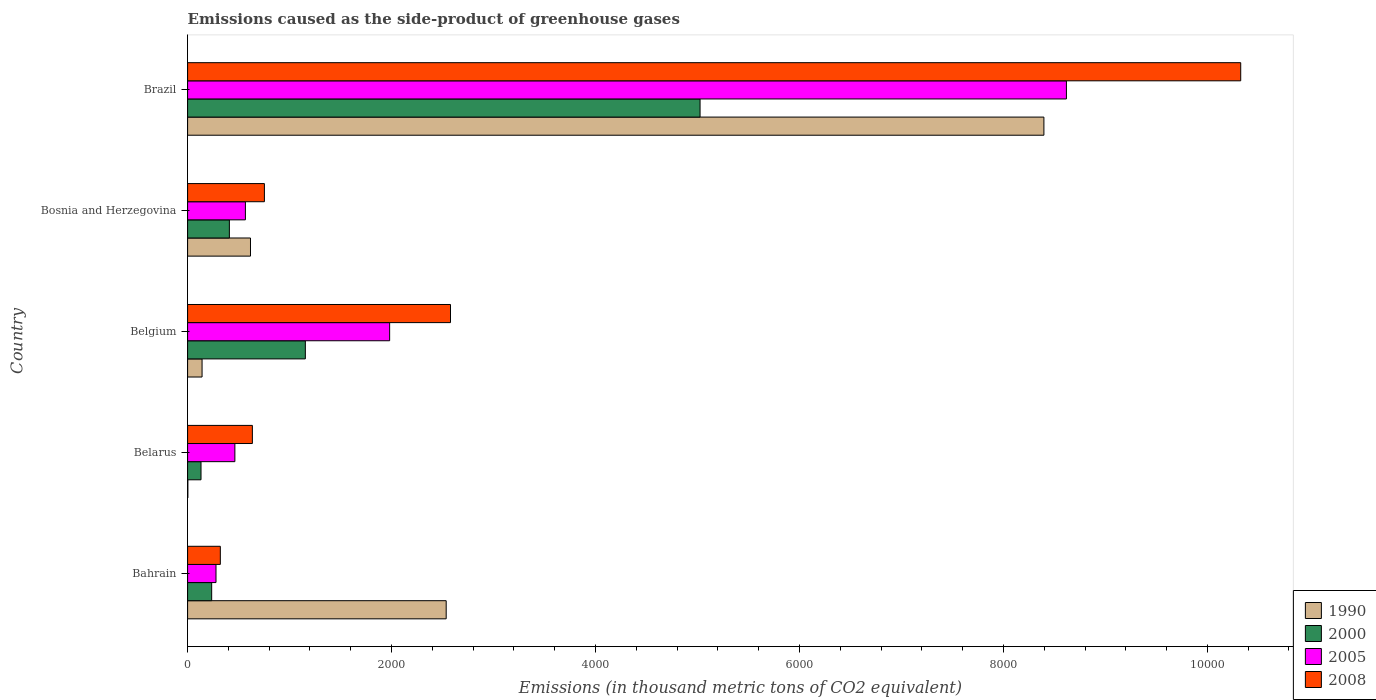Are the number of bars per tick equal to the number of legend labels?
Offer a terse response. Yes. Are the number of bars on each tick of the Y-axis equal?
Offer a very short reply. Yes. How many bars are there on the 4th tick from the top?
Provide a short and direct response. 4. How many bars are there on the 2nd tick from the bottom?
Your answer should be very brief. 4. What is the label of the 2nd group of bars from the top?
Your response must be concise. Bosnia and Herzegovina. In how many cases, is the number of bars for a given country not equal to the number of legend labels?
Offer a very short reply. 0. What is the emissions caused as the side-product of greenhouse gases in 1990 in Brazil?
Your response must be concise. 8396.7. Across all countries, what is the maximum emissions caused as the side-product of greenhouse gases in 2008?
Provide a short and direct response. 1.03e+04. Across all countries, what is the minimum emissions caused as the side-product of greenhouse gases in 2000?
Offer a very short reply. 131.6. In which country was the emissions caused as the side-product of greenhouse gases in 2005 minimum?
Make the answer very short. Bahrain. What is the total emissions caused as the side-product of greenhouse gases in 2008 in the graph?
Your answer should be compact. 1.46e+04. What is the difference between the emissions caused as the side-product of greenhouse gases in 1990 in Bahrain and that in Bosnia and Herzegovina?
Keep it short and to the point. 1919. What is the difference between the emissions caused as the side-product of greenhouse gases in 2000 in Bahrain and the emissions caused as the side-product of greenhouse gases in 1990 in Belarus?
Provide a short and direct response. 233.5. What is the average emissions caused as the side-product of greenhouse gases in 1990 per country?
Your response must be concise. 2338.72. What is the difference between the emissions caused as the side-product of greenhouse gases in 2008 and emissions caused as the side-product of greenhouse gases in 2005 in Brazil?
Your answer should be very brief. 1709.1. In how many countries, is the emissions caused as the side-product of greenhouse gases in 2005 greater than 6400 thousand metric tons?
Your response must be concise. 1. What is the ratio of the emissions caused as the side-product of greenhouse gases in 2005 in Belarus to that in Bosnia and Herzegovina?
Your answer should be very brief. 0.82. What is the difference between the highest and the second highest emissions caused as the side-product of greenhouse gases in 2008?
Your response must be concise. 7748.6. What is the difference between the highest and the lowest emissions caused as the side-product of greenhouse gases in 2005?
Offer a very short reply. 8338.9. In how many countries, is the emissions caused as the side-product of greenhouse gases in 2008 greater than the average emissions caused as the side-product of greenhouse gases in 2008 taken over all countries?
Give a very brief answer. 1. Is the sum of the emissions caused as the side-product of greenhouse gases in 2005 in Belgium and Brazil greater than the maximum emissions caused as the side-product of greenhouse gases in 2008 across all countries?
Your response must be concise. Yes. What does the 2nd bar from the top in Brazil represents?
Offer a very short reply. 2005. Is it the case that in every country, the sum of the emissions caused as the side-product of greenhouse gases in 2005 and emissions caused as the side-product of greenhouse gases in 2000 is greater than the emissions caused as the side-product of greenhouse gases in 2008?
Give a very brief answer. No. Are the values on the major ticks of X-axis written in scientific E-notation?
Your answer should be very brief. No. Does the graph contain any zero values?
Offer a very short reply. No. How many legend labels are there?
Your answer should be very brief. 4. What is the title of the graph?
Keep it short and to the point. Emissions caused as the side-product of greenhouse gases. What is the label or title of the X-axis?
Ensure brevity in your answer.  Emissions (in thousand metric tons of CO2 equivalent). What is the label or title of the Y-axis?
Your answer should be very brief. Country. What is the Emissions (in thousand metric tons of CO2 equivalent) of 1990 in Bahrain?
Your answer should be very brief. 2535.7. What is the Emissions (in thousand metric tons of CO2 equivalent) of 2000 in Bahrain?
Your answer should be very brief. 236.1. What is the Emissions (in thousand metric tons of CO2 equivalent) of 2005 in Bahrain?
Provide a succinct answer. 278.6. What is the Emissions (in thousand metric tons of CO2 equivalent) in 2008 in Bahrain?
Your answer should be very brief. 320.9. What is the Emissions (in thousand metric tons of CO2 equivalent) of 1990 in Belarus?
Provide a short and direct response. 2.6. What is the Emissions (in thousand metric tons of CO2 equivalent) of 2000 in Belarus?
Make the answer very short. 131.6. What is the Emissions (in thousand metric tons of CO2 equivalent) in 2005 in Belarus?
Give a very brief answer. 463.6. What is the Emissions (in thousand metric tons of CO2 equivalent) in 2008 in Belarus?
Offer a terse response. 635.2. What is the Emissions (in thousand metric tons of CO2 equivalent) of 1990 in Belgium?
Offer a very short reply. 141.9. What is the Emissions (in thousand metric tons of CO2 equivalent) of 2000 in Belgium?
Keep it short and to the point. 1154.6. What is the Emissions (in thousand metric tons of CO2 equivalent) of 2005 in Belgium?
Provide a short and direct response. 1981.2. What is the Emissions (in thousand metric tons of CO2 equivalent) in 2008 in Belgium?
Provide a succinct answer. 2578. What is the Emissions (in thousand metric tons of CO2 equivalent) in 1990 in Bosnia and Herzegovina?
Provide a short and direct response. 616.7. What is the Emissions (in thousand metric tons of CO2 equivalent) of 2000 in Bosnia and Herzegovina?
Your response must be concise. 409.7. What is the Emissions (in thousand metric tons of CO2 equivalent) of 2005 in Bosnia and Herzegovina?
Give a very brief answer. 566.9. What is the Emissions (in thousand metric tons of CO2 equivalent) of 2008 in Bosnia and Herzegovina?
Provide a succinct answer. 753.2. What is the Emissions (in thousand metric tons of CO2 equivalent) of 1990 in Brazil?
Offer a terse response. 8396.7. What is the Emissions (in thousand metric tons of CO2 equivalent) of 2000 in Brazil?
Keep it short and to the point. 5025.2. What is the Emissions (in thousand metric tons of CO2 equivalent) in 2005 in Brazil?
Provide a short and direct response. 8617.5. What is the Emissions (in thousand metric tons of CO2 equivalent) in 2008 in Brazil?
Your answer should be very brief. 1.03e+04. Across all countries, what is the maximum Emissions (in thousand metric tons of CO2 equivalent) in 1990?
Offer a very short reply. 8396.7. Across all countries, what is the maximum Emissions (in thousand metric tons of CO2 equivalent) of 2000?
Give a very brief answer. 5025.2. Across all countries, what is the maximum Emissions (in thousand metric tons of CO2 equivalent) in 2005?
Ensure brevity in your answer.  8617.5. Across all countries, what is the maximum Emissions (in thousand metric tons of CO2 equivalent) in 2008?
Your answer should be very brief. 1.03e+04. Across all countries, what is the minimum Emissions (in thousand metric tons of CO2 equivalent) in 2000?
Your answer should be very brief. 131.6. Across all countries, what is the minimum Emissions (in thousand metric tons of CO2 equivalent) of 2005?
Offer a terse response. 278.6. Across all countries, what is the minimum Emissions (in thousand metric tons of CO2 equivalent) in 2008?
Your response must be concise. 320.9. What is the total Emissions (in thousand metric tons of CO2 equivalent) of 1990 in the graph?
Offer a terse response. 1.17e+04. What is the total Emissions (in thousand metric tons of CO2 equivalent) in 2000 in the graph?
Your response must be concise. 6957.2. What is the total Emissions (in thousand metric tons of CO2 equivalent) in 2005 in the graph?
Make the answer very short. 1.19e+04. What is the total Emissions (in thousand metric tons of CO2 equivalent) of 2008 in the graph?
Provide a succinct answer. 1.46e+04. What is the difference between the Emissions (in thousand metric tons of CO2 equivalent) of 1990 in Bahrain and that in Belarus?
Give a very brief answer. 2533.1. What is the difference between the Emissions (in thousand metric tons of CO2 equivalent) of 2000 in Bahrain and that in Belarus?
Ensure brevity in your answer.  104.5. What is the difference between the Emissions (in thousand metric tons of CO2 equivalent) in 2005 in Bahrain and that in Belarus?
Your response must be concise. -185. What is the difference between the Emissions (in thousand metric tons of CO2 equivalent) of 2008 in Bahrain and that in Belarus?
Provide a short and direct response. -314.3. What is the difference between the Emissions (in thousand metric tons of CO2 equivalent) in 1990 in Bahrain and that in Belgium?
Offer a very short reply. 2393.8. What is the difference between the Emissions (in thousand metric tons of CO2 equivalent) in 2000 in Bahrain and that in Belgium?
Ensure brevity in your answer.  -918.5. What is the difference between the Emissions (in thousand metric tons of CO2 equivalent) of 2005 in Bahrain and that in Belgium?
Your response must be concise. -1702.6. What is the difference between the Emissions (in thousand metric tons of CO2 equivalent) in 2008 in Bahrain and that in Belgium?
Your response must be concise. -2257.1. What is the difference between the Emissions (in thousand metric tons of CO2 equivalent) in 1990 in Bahrain and that in Bosnia and Herzegovina?
Offer a terse response. 1919. What is the difference between the Emissions (in thousand metric tons of CO2 equivalent) of 2000 in Bahrain and that in Bosnia and Herzegovina?
Make the answer very short. -173.6. What is the difference between the Emissions (in thousand metric tons of CO2 equivalent) of 2005 in Bahrain and that in Bosnia and Herzegovina?
Offer a very short reply. -288.3. What is the difference between the Emissions (in thousand metric tons of CO2 equivalent) of 2008 in Bahrain and that in Bosnia and Herzegovina?
Provide a succinct answer. -432.3. What is the difference between the Emissions (in thousand metric tons of CO2 equivalent) in 1990 in Bahrain and that in Brazil?
Provide a short and direct response. -5861. What is the difference between the Emissions (in thousand metric tons of CO2 equivalent) of 2000 in Bahrain and that in Brazil?
Make the answer very short. -4789.1. What is the difference between the Emissions (in thousand metric tons of CO2 equivalent) in 2005 in Bahrain and that in Brazil?
Your response must be concise. -8338.9. What is the difference between the Emissions (in thousand metric tons of CO2 equivalent) in 2008 in Bahrain and that in Brazil?
Provide a succinct answer. -1.00e+04. What is the difference between the Emissions (in thousand metric tons of CO2 equivalent) of 1990 in Belarus and that in Belgium?
Make the answer very short. -139.3. What is the difference between the Emissions (in thousand metric tons of CO2 equivalent) in 2000 in Belarus and that in Belgium?
Your answer should be compact. -1023. What is the difference between the Emissions (in thousand metric tons of CO2 equivalent) in 2005 in Belarus and that in Belgium?
Your response must be concise. -1517.6. What is the difference between the Emissions (in thousand metric tons of CO2 equivalent) of 2008 in Belarus and that in Belgium?
Give a very brief answer. -1942.8. What is the difference between the Emissions (in thousand metric tons of CO2 equivalent) in 1990 in Belarus and that in Bosnia and Herzegovina?
Ensure brevity in your answer.  -614.1. What is the difference between the Emissions (in thousand metric tons of CO2 equivalent) of 2000 in Belarus and that in Bosnia and Herzegovina?
Your answer should be very brief. -278.1. What is the difference between the Emissions (in thousand metric tons of CO2 equivalent) in 2005 in Belarus and that in Bosnia and Herzegovina?
Offer a terse response. -103.3. What is the difference between the Emissions (in thousand metric tons of CO2 equivalent) in 2008 in Belarus and that in Bosnia and Herzegovina?
Offer a very short reply. -118. What is the difference between the Emissions (in thousand metric tons of CO2 equivalent) of 1990 in Belarus and that in Brazil?
Ensure brevity in your answer.  -8394.1. What is the difference between the Emissions (in thousand metric tons of CO2 equivalent) in 2000 in Belarus and that in Brazil?
Ensure brevity in your answer.  -4893.6. What is the difference between the Emissions (in thousand metric tons of CO2 equivalent) of 2005 in Belarus and that in Brazil?
Make the answer very short. -8153.9. What is the difference between the Emissions (in thousand metric tons of CO2 equivalent) of 2008 in Belarus and that in Brazil?
Offer a very short reply. -9691.4. What is the difference between the Emissions (in thousand metric tons of CO2 equivalent) in 1990 in Belgium and that in Bosnia and Herzegovina?
Ensure brevity in your answer.  -474.8. What is the difference between the Emissions (in thousand metric tons of CO2 equivalent) in 2000 in Belgium and that in Bosnia and Herzegovina?
Provide a succinct answer. 744.9. What is the difference between the Emissions (in thousand metric tons of CO2 equivalent) of 2005 in Belgium and that in Bosnia and Herzegovina?
Your response must be concise. 1414.3. What is the difference between the Emissions (in thousand metric tons of CO2 equivalent) in 2008 in Belgium and that in Bosnia and Herzegovina?
Your answer should be very brief. 1824.8. What is the difference between the Emissions (in thousand metric tons of CO2 equivalent) in 1990 in Belgium and that in Brazil?
Offer a very short reply. -8254.8. What is the difference between the Emissions (in thousand metric tons of CO2 equivalent) of 2000 in Belgium and that in Brazil?
Your answer should be very brief. -3870.6. What is the difference between the Emissions (in thousand metric tons of CO2 equivalent) in 2005 in Belgium and that in Brazil?
Give a very brief answer. -6636.3. What is the difference between the Emissions (in thousand metric tons of CO2 equivalent) of 2008 in Belgium and that in Brazil?
Ensure brevity in your answer.  -7748.6. What is the difference between the Emissions (in thousand metric tons of CO2 equivalent) in 1990 in Bosnia and Herzegovina and that in Brazil?
Provide a short and direct response. -7780. What is the difference between the Emissions (in thousand metric tons of CO2 equivalent) of 2000 in Bosnia and Herzegovina and that in Brazil?
Give a very brief answer. -4615.5. What is the difference between the Emissions (in thousand metric tons of CO2 equivalent) of 2005 in Bosnia and Herzegovina and that in Brazil?
Ensure brevity in your answer.  -8050.6. What is the difference between the Emissions (in thousand metric tons of CO2 equivalent) in 2008 in Bosnia and Herzegovina and that in Brazil?
Ensure brevity in your answer.  -9573.4. What is the difference between the Emissions (in thousand metric tons of CO2 equivalent) of 1990 in Bahrain and the Emissions (in thousand metric tons of CO2 equivalent) of 2000 in Belarus?
Ensure brevity in your answer.  2404.1. What is the difference between the Emissions (in thousand metric tons of CO2 equivalent) of 1990 in Bahrain and the Emissions (in thousand metric tons of CO2 equivalent) of 2005 in Belarus?
Offer a terse response. 2072.1. What is the difference between the Emissions (in thousand metric tons of CO2 equivalent) of 1990 in Bahrain and the Emissions (in thousand metric tons of CO2 equivalent) of 2008 in Belarus?
Give a very brief answer. 1900.5. What is the difference between the Emissions (in thousand metric tons of CO2 equivalent) in 2000 in Bahrain and the Emissions (in thousand metric tons of CO2 equivalent) in 2005 in Belarus?
Provide a succinct answer. -227.5. What is the difference between the Emissions (in thousand metric tons of CO2 equivalent) of 2000 in Bahrain and the Emissions (in thousand metric tons of CO2 equivalent) of 2008 in Belarus?
Ensure brevity in your answer.  -399.1. What is the difference between the Emissions (in thousand metric tons of CO2 equivalent) in 2005 in Bahrain and the Emissions (in thousand metric tons of CO2 equivalent) in 2008 in Belarus?
Make the answer very short. -356.6. What is the difference between the Emissions (in thousand metric tons of CO2 equivalent) in 1990 in Bahrain and the Emissions (in thousand metric tons of CO2 equivalent) in 2000 in Belgium?
Your answer should be very brief. 1381.1. What is the difference between the Emissions (in thousand metric tons of CO2 equivalent) in 1990 in Bahrain and the Emissions (in thousand metric tons of CO2 equivalent) in 2005 in Belgium?
Keep it short and to the point. 554.5. What is the difference between the Emissions (in thousand metric tons of CO2 equivalent) of 1990 in Bahrain and the Emissions (in thousand metric tons of CO2 equivalent) of 2008 in Belgium?
Provide a short and direct response. -42.3. What is the difference between the Emissions (in thousand metric tons of CO2 equivalent) in 2000 in Bahrain and the Emissions (in thousand metric tons of CO2 equivalent) in 2005 in Belgium?
Provide a short and direct response. -1745.1. What is the difference between the Emissions (in thousand metric tons of CO2 equivalent) in 2000 in Bahrain and the Emissions (in thousand metric tons of CO2 equivalent) in 2008 in Belgium?
Your answer should be very brief. -2341.9. What is the difference between the Emissions (in thousand metric tons of CO2 equivalent) in 2005 in Bahrain and the Emissions (in thousand metric tons of CO2 equivalent) in 2008 in Belgium?
Offer a very short reply. -2299.4. What is the difference between the Emissions (in thousand metric tons of CO2 equivalent) of 1990 in Bahrain and the Emissions (in thousand metric tons of CO2 equivalent) of 2000 in Bosnia and Herzegovina?
Give a very brief answer. 2126. What is the difference between the Emissions (in thousand metric tons of CO2 equivalent) of 1990 in Bahrain and the Emissions (in thousand metric tons of CO2 equivalent) of 2005 in Bosnia and Herzegovina?
Your answer should be compact. 1968.8. What is the difference between the Emissions (in thousand metric tons of CO2 equivalent) in 1990 in Bahrain and the Emissions (in thousand metric tons of CO2 equivalent) in 2008 in Bosnia and Herzegovina?
Offer a terse response. 1782.5. What is the difference between the Emissions (in thousand metric tons of CO2 equivalent) of 2000 in Bahrain and the Emissions (in thousand metric tons of CO2 equivalent) of 2005 in Bosnia and Herzegovina?
Ensure brevity in your answer.  -330.8. What is the difference between the Emissions (in thousand metric tons of CO2 equivalent) in 2000 in Bahrain and the Emissions (in thousand metric tons of CO2 equivalent) in 2008 in Bosnia and Herzegovina?
Your answer should be very brief. -517.1. What is the difference between the Emissions (in thousand metric tons of CO2 equivalent) in 2005 in Bahrain and the Emissions (in thousand metric tons of CO2 equivalent) in 2008 in Bosnia and Herzegovina?
Keep it short and to the point. -474.6. What is the difference between the Emissions (in thousand metric tons of CO2 equivalent) of 1990 in Bahrain and the Emissions (in thousand metric tons of CO2 equivalent) of 2000 in Brazil?
Provide a succinct answer. -2489.5. What is the difference between the Emissions (in thousand metric tons of CO2 equivalent) of 1990 in Bahrain and the Emissions (in thousand metric tons of CO2 equivalent) of 2005 in Brazil?
Keep it short and to the point. -6081.8. What is the difference between the Emissions (in thousand metric tons of CO2 equivalent) in 1990 in Bahrain and the Emissions (in thousand metric tons of CO2 equivalent) in 2008 in Brazil?
Give a very brief answer. -7790.9. What is the difference between the Emissions (in thousand metric tons of CO2 equivalent) of 2000 in Bahrain and the Emissions (in thousand metric tons of CO2 equivalent) of 2005 in Brazil?
Provide a short and direct response. -8381.4. What is the difference between the Emissions (in thousand metric tons of CO2 equivalent) of 2000 in Bahrain and the Emissions (in thousand metric tons of CO2 equivalent) of 2008 in Brazil?
Give a very brief answer. -1.01e+04. What is the difference between the Emissions (in thousand metric tons of CO2 equivalent) of 2005 in Bahrain and the Emissions (in thousand metric tons of CO2 equivalent) of 2008 in Brazil?
Your answer should be compact. -1.00e+04. What is the difference between the Emissions (in thousand metric tons of CO2 equivalent) in 1990 in Belarus and the Emissions (in thousand metric tons of CO2 equivalent) in 2000 in Belgium?
Keep it short and to the point. -1152. What is the difference between the Emissions (in thousand metric tons of CO2 equivalent) of 1990 in Belarus and the Emissions (in thousand metric tons of CO2 equivalent) of 2005 in Belgium?
Your response must be concise. -1978.6. What is the difference between the Emissions (in thousand metric tons of CO2 equivalent) of 1990 in Belarus and the Emissions (in thousand metric tons of CO2 equivalent) of 2008 in Belgium?
Your response must be concise. -2575.4. What is the difference between the Emissions (in thousand metric tons of CO2 equivalent) of 2000 in Belarus and the Emissions (in thousand metric tons of CO2 equivalent) of 2005 in Belgium?
Ensure brevity in your answer.  -1849.6. What is the difference between the Emissions (in thousand metric tons of CO2 equivalent) in 2000 in Belarus and the Emissions (in thousand metric tons of CO2 equivalent) in 2008 in Belgium?
Your response must be concise. -2446.4. What is the difference between the Emissions (in thousand metric tons of CO2 equivalent) in 2005 in Belarus and the Emissions (in thousand metric tons of CO2 equivalent) in 2008 in Belgium?
Your answer should be very brief. -2114.4. What is the difference between the Emissions (in thousand metric tons of CO2 equivalent) of 1990 in Belarus and the Emissions (in thousand metric tons of CO2 equivalent) of 2000 in Bosnia and Herzegovina?
Offer a very short reply. -407.1. What is the difference between the Emissions (in thousand metric tons of CO2 equivalent) of 1990 in Belarus and the Emissions (in thousand metric tons of CO2 equivalent) of 2005 in Bosnia and Herzegovina?
Your answer should be very brief. -564.3. What is the difference between the Emissions (in thousand metric tons of CO2 equivalent) in 1990 in Belarus and the Emissions (in thousand metric tons of CO2 equivalent) in 2008 in Bosnia and Herzegovina?
Provide a succinct answer. -750.6. What is the difference between the Emissions (in thousand metric tons of CO2 equivalent) in 2000 in Belarus and the Emissions (in thousand metric tons of CO2 equivalent) in 2005 in Bosnia and Herzegovina?
Provide a succinct answer. -435.3. What is the difference between the Emissions (in thousand metric tons of CO2 equivalent) in 2000 in Belarus and the Emissions (in thousand metric tons of CO2 equivalent) in 2008 in Bosnia and Herzegovina?
Offer a very short reply. -621.6. What is the difference between the Emissions (in thousand metric tons of CO2 equivalent) in 2005 in Belarus and the Emissions (in thousand metric tons of CO2 equivalent) in 2008 in Bosnia and Herzegovina?
Provide a short and direct response. -289.6. What is the difference between the Emissions (in thousand metric tons of CO2 equivalent) of 1990 in Belarus and the Emissions (in thousand metric tons of CO2 equivalent) of 2000 in Brazil?
Offer a terse response. -5022.6. What is the difference between the Emissions (in thousand metric tons of CO2 equivalent) in 1990 in Belarus and the Emissions (in thousand metric tons of CO2 equivalent) in 2005 in Brazil?
Keep it short and to the point. -8614.9. What is the difference between the Emissions (in thousand metric tons of CO2 equivalent) in 1990 in Belarus and the Emissions (in thousand metric tons of CO2 equivalent) in 2008 in Brazil?
Keep it short and to the point. -1.03e+04. What is the difference between the Emissions (in thousand metric tons of CO2 equivalent) in 2000 in Belarus and the Emissions (in thousand metric tons of CO2 equivalent) in 2005 in Brazil?
Keep it short and to the point. -8485.9. What is the difference between the Emissions (in thousand metric tons of CO2 equivalent) of 2000 in Belarus and the Emissions (in thousand metric tons of CO2 equivalent) of 2008 in Brazil?
Provide a succinct answer. -1.02e+04. What is the difference between the Emissions (in thousand metric tons of CO2 equivalent) of 2005 in Belarus and the Emissions (in thousand metric tons of CO2 equivalent) of 2008 in Brazil?
Make the answer very short. -9863. What is the difference between the Emissions (in thousand metric tons of CO2 equivalent) in 1990 in Belgium and the Emissions (in thousand metric tons of CO2 equivalent) in 2000 in Bosnia and Herzegovina?
Give a very brief answer. -267.8. What is the difference between the Emissions (in thousand metric tons of CO2 equivalent) in 1990 in Belgium and the Emissions (in thousand metric tons of CO2 equivalent) in 2005 in Bosnia and Herzegovina?
Ensure brevity in your answer.  -425. What is the difference between the Emissions (in thousand metric tons of CO2 equivalent) in 1990 in Belgium and the Emissions (in thousand metric tons of CO2 equivalent) in 2008 in Bosnia and Herzegovina?
Your answer should be compact. -611.3. What is the difference between the Emissions (in thousand metric tons of CO2 equivalent) of 2000 in Belgium and the Emissions (in thousand metric tons of CO2 equivalent) of 2005 in Bosnia and Herzegovina?
Your answer should be very brief. 587.7. What is the difference between the Emissions (in thousand metric tons of CO2 equivalent) in 2000 in Belgium and the Emissions (in thousand metric tons of CO2 equivalent) in 2008 in Bosnia and Herzegovina?
Provide a short and direct response. 401.4. What is the difference between the Emissions (in thousand metric tons of CO2 equivalent) of 2005 in Belgium and the Emissions (in thousand metric tons of CO2 equivalent) of 2008 in Bosnia and Herzegovina?
Make the answer very short. 1228. What is the difference between the Emissions (in thousand metric tons of CO2 equivalent) of 1990 in Belgium and the Emissions (in thousand metric tons of CO2 equivalent) of 2000 in Brazil?
Offer a terse response. -4883.3. What is the difference between the Emissions (in thousand metric tons of CO2 equivalent) in 1990 in Belgium and the Emissions (in thousand metric tons of CO2 equivalent) in 2005 in Brazil?
Provide a succinct answer. -8475.6. What is the difference between the Emissions (in thousand metric tons of CO2 equivalent) in 1990 in Belgium and the Emissions (in thousand metric tons of CO2 equivalent) in 2008 in Brazil?
Your answer should be compact. -1.02e+04. What is the difference between the Emissions (in thousand metric tons of CO2 equivalent) of 2000 in Belgium and the Emissions (in thousand metric tons of CO2 equivalent) of 2005 in Brazil?
Your response must be concise. -7462.9. What is the difference between the Emissions (in thousand metric tons of CO2 equivalent) of 2000 in Belgium and the Emissions (in thousand metric tons of CO2 equivalent) of 2008 in Brazil?
Give a very brief answer. -9172. What is the difference between the Emissions (in thousand metric tons of CO2 equivalent) of 2005 in Belgium and the Emissions (in thousand metric tons of CO2 equivalent) of 2008 in Brazil?
Offer a terse response. -8345.4. What is the difference between the Emissions (in thousand metric tons of CO2 equivalent) in 1990 in Bosnia and Herzegovina and the Emissions (in thousand metric tons of CO2 equivalent) in 2000 in Brazil?
Provide a short and direct response. -4408.5. What is the difference between the Emissions (in thousand metric tons of CO2 equivalent) of 1990 in Bosnia and Herzegovina and the Emissions (in thousand metric tons of CO2 equivalent) of 2005 in Brazil?
Your answer should be very brief. -8000.8. What is the difference between the Emissions (in thousand metric tons of CO2 equivalent) in 1990 in Bosnia and Herzegovina and the Emissions (in thousand metric tons of CO2 equivalent) in 2008 in Brazil?
Your answer should be very brief. -9709.9. What is the difference between the Emissions (in thousand metric tons of CO2 equivalent) in 2000 in Bosnia and Herzegovina and the Emissions (in thousand metric tons of CO2 equivalent) in 2005 in Brazil?
Offer a terse response. -8207.8. What is the difference between the Emissions (in thousand metric tons of CO2 equivalent) in 2000 in Bosnia and Herzegovina and the Emissions (in thousand metric tons of CO2 equivalent) in 2008 in Brazil?
Offer a terse response. -9916.9. What is the difference between the Emissions (in thousand metric tons of CO2 equivalent) of 2005 in Bosnia and Herzegovina and the Emissions (in thousand metric tons of CO2 equivalent) of 2008 in Brazil?
Your answer should be very brief. -9759.7. What is the average Emissions (in thousand metric tons of CO2 equivalent) in 1990 per country?
Your answer should be very brief. 2338.72. What is the average Emissions (in thousand metric tons of CO2 equivalent) in 2000 per country?
Give a very brief answer. 1391.44. What is the average Emissions (in thousand metric tons of CO2 equivalent) of 2005 per country?
Your answer should be very brief. 2381.56. What is the average Emissions (in thousand metric tons of CO2 equivalent) of 2008 per country?
Make the answer very short. 2922.78. What is the difference between the Emissions (in thousand metric tons of CO2 equivalent) of 1990 and Emissions (in thousand metric tons of CO2 equivalent) of 2000 in Bahrain?
Offer a very short reply. 2299.6. What is the difference between the Emissions (in thousand metric tons of CO2 equivalent) of 1990 and Emissions (in thousand metric tons of CO2 equivalent) of 2005 in Bahrain?
Give a very brief answer. 2257.1. What is the difference between the Emissions (in thousand metric tons of CO2 equivalent) in 1990 and Emissions (in thousand metric tons of CO2 equivalent) in 2008 in Bahrain?
Make the answer very short. 2214.8. What is the difference between the Emissions (in thousand metric tons of CO2 equivalent) in 2000 and Emissions (in thousand metric tons of CO2 equivalent) in 2005 in Bahrain?
Offer a terse response. -42.5. What is the difference between the Emissions (in thousand metric tons of CO2 equivalent) in 2000 and Emissions (in thousand metric tons of CO2 equivalent) in 2008 in Bahrain?
Provide a succinct answer. -84.8. What is the difference between the Emissions (in thousand metric tons of CO2 equivalent) in 2005 and Emissions (in thousand metric tons of CO2 equivalent) in 2008 in Bahrain?
Keep it short and to the point. -42.3. What is the difference between the Emissions (in thousand metric tons of CO2 equivalent) of 1990 and Emissions (in thousand metric tons of CO2 equivalent) of 2000 in Belarus?
Provide a succinct answer. -129. What is the difference between the Emissions (in thousand metric tons of CO2 equivalent) of 1990 and Emissions (in thousand metric tons of CO2 equivalent) of 2005 in Belarus?
Keep it short and to the point. -461. What is the difference between the Emissions (in thousand metric tons of CO2 equivalent) in 1990 and Emissions (in thousand metric tons of CO2 equivalent) in 2008 in Belarus?
Ensure brevity in your answer.  -632.6. What is the difference between the Emissions (in thousand metric tons of CO2 equivalent) of 2000 and Emissions (in thousand metric tons of CO2 equivalent) of 2005 in Belarus?
Provide a succinct answer. -332. What is the difference between the Emissions (in thousand metric tons of CO2 equivalent) of 2000 and Emissions (in thousand metric tons of CO2 equivalent) of 2008 in Belarus?
Your answer should be very brief. -503.6. What is the difference between the Emissions (in thousand metric tons of CO2 equivalent) in 2005 and Emissions (in thousand metric tons of CO2 equivalent) in 2008 in Belarus?
Your answer should be compact. -171.6. What is the difference between the Emissions (in thousand metric tons of CO2 equivalent) in 1990 and Emissions (in thousand metric tons of CO2 equivalent) in 2000 in Belgium?
Give a very brief answer. -1012.7. What is the difference between the Emissions (in thousand metric tons of CO2 equivalent) of 1990 and Emissions (in thousand metric tons of CO2 equivalent) of 2005 in Belgium?
Your answer should be compact. -1839.3. What is the difference between the Emissions (in thousand metric tons of CO2 equivalent) in 1990 and Emissions (in thousand metric tons of CO2 equivalent) in 2008 in Belgium?
Provide a short and direct response. -2436.1. What is the difference between the Emissions (in thousand metric tons of CO2 equivalent) of 2000 and Emissions (in thousand metric tons of CO2 equivalent) of 2005 in Belgium?
Give a very brief answer. -826.6. What is the difference between the Emissions (in thousand metric tons of CO2 equivalent) of 2000 and Emissions (in thousand metric tons of CO2 equivalent) of 2008 in Belgium?
Keep it short and to the point. -1423.4. What is the difference between the Emissions (in thousand metric tons of CO2 equivalent) of 2005 and Emissions (in thousand metric tons of CO2 equivalent) of 2008 in Belgium?
Your answer should be very brief. -596.8. What is the difference between the Emissions (in thousand metric tons of CO2 equivalent) of 1990 and Emissions (in thousand metric tons of CO2 equivalent) of 2000 in Bosnia and Herzegovina?
Your answer should be compact. 207. What is the difference between the Emissions (in thousand metric tons of CO2 equivalent) of 1990 and Emissions (in thousand metric tons of CO2 equivalent) of 2005 in Bosnia and Herzegovina?
Offer a very short reply. 49.8. What is the difference between the Emissions (in thousand metric tons of CO2 equivalent) in 1990 and Emissions (in thousand metric tons of CO2 equivalent) in 2008 in Bosnia and Herzegovina?
Keep it short and to the point. -136.5. What is the difference between the Emissions (in thousand metric tons of CO2 equivalent) of 2000 and Emissions (in thousand metric tons of CO2 equivalent) of 2005 in Bosnia and Herzegovina?
Provide a short and direct response. -157.2. What is the difference between the Emissions (in thousand metric tons of CO2 equivalent) in 2000 and Emissions (in thousand metric tons of CO2 equivalent) in 2008 in Bosnia and Herzegovina?
Ensure brevity in your answer.  -343.5. What is the difference between the Emissions (in thousand metric tons of CO2 equivalent) of 2005 and Emissions (in thousand metric tons of CO2 equivalent) of 2008 in Bosnia and Herzegovina?
Keep it short and to the point. -186.3. What is the difference between the Emissions (in thousand metric tons of CO2 equivalent) in 1990 and Emissions (in thousand metric tons of CO2 equivalent) in 2000 in Brazil?
Your answer should be compact. 3371.5. What is the difference between the Emissions (in thousand metric tons of CO2 equivalent) in 1990 and Emissions (in thousand metric tons of CO2 equivalent) in 2005 in Brazil?
Your response must be concise. -220.8. What is the difference between the Emissions (in thousand metric tons of CO2 equivalent) in 1990 and Emissions (in thousand metric tons of CO2 equivalent) in 2008 in Brazil?
Offer a very short reply. -1929.9. What is the difference between the Emissions (in thousand metric tons of CO2 equivalent) in 2000 and Emissions (in thousand metric tons of CO2 equivalent) in 2005 in Brazil?
Your answer should be very brief. -3592.3. What is the difference between the Emissions (in thousand metric tons of CO2 equivalent) in 2000 and Emissions (in thousand metric tons of CO2 equivalent) in 2008 in Brazil?
Your answer should be very brief. -5301.4. What is the difference between the Emissions (in thousand metric tons of CO2 equivalent) in 2005 and Emissions (in thousand metric tons of CO2 equivalent) in 2008 in Brazil?
Your answer should be compact. -1709.1. What is the ratio of the Emissions (in thousand metric tons of CO2 equivalent) of 1990 in Bahrain to that in Belarus?
Provide a short and direct response. 975.27. What is the ratio of the Emissions (in thousand metric tons of CO2 equivalent) in 2000 in Bahrain to that in Belarus?
Your answer should be very brief. 1.79. What is the ratio of the Emissions (in thousand metric tons of CO2 equivalent) in 2005 in Bahrain to that in Belarus?
Provide a succinct answer. 0.6. What is the ratio of the Emissions (in thousand metric tons of CO2 equivalent) in 2008 in Bahrain to that in Belarus?
Your answer should be very brief. 0.51. What is the ratio of the Emissions (in thousand metric tons of CO2 equivalent) in 1990 in Bahrain to that in Belgium?
Make the answer very short. 17.87. What is the ratio of the Emissions (in thousand metric tons of CO2 equivalent) in 2000 in Bahrain to that in Belgium?
Provide a short and direct response. 0.2. What is the ratio of the Emissions (in thousand metric tons of CO2 equivalent) in 2005 in Bahrain to that in Belgium?
Ensure brevity in your answer.  0.14. What is the ratio of the Emissions (in thousand metric tons of CO2 equivalent) of 2008 in Bahrain to that in Belgium?
Make the answer very short. 0.12. What is the ratio of the Emissions (in thousand metric tons of CO2 equivalent) of 1990 in Bahrain to that in Bosnia and Herzegovina?
Provide a short and direct response. 4.11. What is the ratio of the Emissions (in thousand metric tons of CO2 equivalent) in 2000 in Bahrain to that in Bosnia and Herzegovina?
Keep it short and to the point. 0.58. What is the ratio of the Emissions (in thousand metric tons of CO2 equivalent) in 2005 in Bahrain to that in Bosnia and Herzegovina?
Your answer should be very brief. 0.49. What is the ratio of the Emissions (in thousand metric tons of CO2 equivalent) in 2008 in Bahrain to that in Bosnia and Herzegovina?
Your response must be concise. 0.43. What is the ratio of the Emissions (in thousand metric tons of CO2 equivalent) in 1990 in Bahrain to that in Brazil?
Provide a short and direct response. 0.3. What is the ratio of the Emissions (in thousand metric tons of CO2 equivalent) of 2000 in Bahrain to that in Brazil?
Offer a very short reply. 0.05. What is the ratio of the Emissions (in thousand metric tons of CO2 equivalent) in 2005 in Bahrain to that in Brazil?
Your answer should be very brief. 0.03. What is the ratio of the Emissions (in thousand metric tons of CO2 equivalent) in 2008 in Bahrain to that in Brazil?
Ensure brevity in your answer.  0.03. What is the ratio of the Emissions (in thousand metric tons of CO2 equivalent) in 1990 in Belarus to that in Belgium?
Give a very brief answer. 0.02. What is the ratio of the Emissions (in thousand metric tons of CO2 equivalent) of 2000 in Belarus to that in Belgium?
Make the answer very short. 0.11. What is the ratio of the Emissions (in thousand metric tons of CO2 equivalent) in 2005 in Belarus to that in Belgium?
Offer a terse response. 0.23. What is the ratio of the Emissions (in thousand metric tons of CO2 equivalent) in 2008 in Belarus to that in Belgium?
Provide a succinct answer. 0.25. What is the ratio of the Emissions (in thousand metric tons of CO2 equivalent) in 1990 in Belarus to that in Bosnia and Herzegovina?
Provide a short and direct response. 0. What is the ratio of the Emissions (in thousand metric tons of CO2 equivalent) of 2000 in Belarus to that in Bosnia and Herzegovina?
Your answer should be compact. 0.32. What is the ratio of the Emissions (in thousand metric tons of CO2 equivalent) in 2005 in Belarus to that in Bosnia and Herzegovina?
Make the answer very short. 0.82. What is the ratio of the Emissions (in thousand metric tons of CO2 equivalent) of 2008 in Belarus to that in Bosnia and Herzegovina?
Provide a succinct answer. 0.84. What is the ratio of the Emissions (in thousand metric tons of CO2 equivalent) in 2000 in Belarus to that in Brazil?
Provide a short and direct response. 0.03. What is the ratio of the Emissions (in thousand metric tons of CO2 equivalent) in 2005 in Belarus to that in Brazil?
Give a very brief answer. 0.05. What is the ratio of the Emissions (in thousand metric tons of CO2 equivalent) of 2008 in Belarus to that in Brazil?
Offer a very short reply. 0.06. What is the ratio of the Emissions (in thousand metric tons of CO2 equivalent) of 1990 in Belgium to that in Bosnia and Herzegovina?
Offer a terse response. 0.23. What is the ratio of the Emissions (in thousand metric tons of CO2 equivalent) in 2000 in Belgium to that in Bosnia and Herzegovina?
Keep it short and to the point. 2.82. What is the ratio of the Emissions (in thousand metric tons of CO2 equivalent) in 2005 in Belgium to that in Bosnia and Herzegovina?
Provide a succinct answer. 3.49. What is the ratio of the Emissions (in thousand metric tons of CO2 equivalent) in 2008 in Belgium to that in Bosnia and Herzegovina?
Your answer should be compact. 3.42. What is the ratio of the Emissions (in thousand metric tons of CO2 equivalent) of 1990 in Belgium to that in Brazil?
Provide a succinct answer. 0.02. What is the ratio of the Emissions (in thousand metric tons of CO2 equivalent) of 2000 in Belgium to that in Brazil?
Your response must be concise. 0.23. What is the ratio of the Emissions (in thousand metric tons of CO2 equivalent) of 2005 in Belgium to that in Brazil?
Offer a terse response. 0.23. What is the ratio of the Emissions (in thousand metric tons of CO2 equivalent) in 2008 in Belgium to that in Brazil?
Your answer should be very brief. 0.25. What is the ratio of the Emissions (in thousand metric tons of CO2 equivalent) in 1990 in Bosnia and Herzegovina to that in Brazil?
Your answer should be compact. 0.07. What is the ratio of the Emissions (in thousand metric tons of CO2 equivalent) of 2000 in Bosnia and Herzegovina to that in Brazil?
Provide a succinct answer. 0.08. What is the ratio of the Emissions (in thousand metric tons of CO2 equivalent) in 2005 in Bosnia and Herzegovina to that in Brazil?
Keep it short and to the point. 0.07. What is the ratio of the Emissions (in thousand metric tons of CO2 equivalent) of 2008 in Bosnia and Herzegovina to that in Brazil?
Make the answer very short. 0.07. What is the difference between the highest and the second highest Emissions (in thousand metric tons of CO2 equivalent) of 1990?
Provide a short and direct response. 5861. What is the difference between the highest and the second highest Emissions (in thousand metric tons of CO2 equivalent) of 2000?
Offer a very short reply. 3870.6. What is the difference between the highest and the second highest Emissions (in thousand metric tons of CO2 equivalent) of 2005?
Ensure brevity in your answer.  6636.3. What is the difference between the highest and the second highest Emissions (in thousand metric tons of CO2 equivalent) of 2008?
Your response must be concise. 7748.6. What is the difference between the highest and the lowest Emissions (in thousand metric tons of CO2 equivalent) of 1990?
Ensure brevity in your answer.  8394.1. What is the difference between the highest and the lowest Emissions (in thousand metric tons of CO2 equivalent) of 2000?
Provide a succinct answer. 4893.6. What is the difference between the highest and the lowest Emissions (in thousand metric tons of CO2 equivalent) in 2005?
Your response must be concise. 8338.9. What is the difference between the highest and the lowest Emissions (in thousand metric tons of CO2 equivalent) in 2008?
Your answer should be very brief. 1.00e+04. 